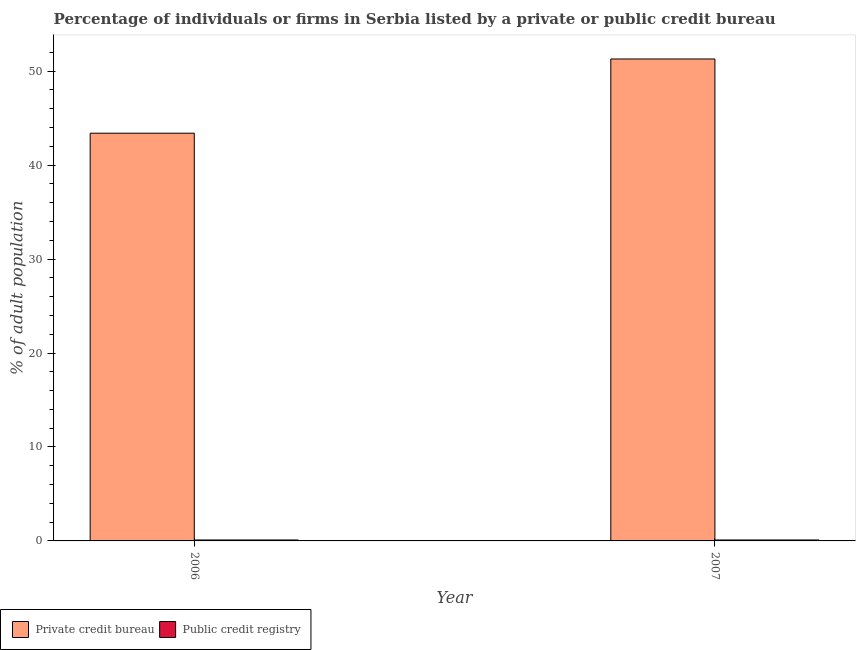How many different coloured bars are there?
Your response must be concise. 2. How many groups of bars are there?
Make the answer very short. 2. Are the number of bars on each tick of the X-axis equal?
Offer a very short reply. Yes. What is the label of the 2nd group of bars from the left?
Your answer should be compact. 2007. What is the percentage of firms listed by private credit bureau in 2006?
Ensure brevity in your answer.  43.4. Across all years, what is the maximum percentage of firms listed by private credit bureau?
Keep it short and to the point. 51.3. Across all years, what is the minimum percentage of firms listed by private credit bureau?
Give a very brief answer. 43.4. In which year was the percentage of firms listed by public credit bureau minimum?
Make the answer very short. 2006. What is the total percentage of firms listed by private credit bureau in the graph?
Provide a short and direct response. 94.7. What is the difference between the percentage of firms listed by public credit bureau in 2006 and that in 2007?
Your answer should be very brief. 0. What is the difference between the percentage of firms listed by public credit bureau in 2006 and the percentage of firms listed by private credit bureau in 2007?
Make the answer very short. 0. What is the average percentage of firms listed by private credit bureau per year?
Make the answer very short. 47.35. In the year 2007, what is the difference between the percentage of firms listed by private credit bureau and percentage of firms listed by public credit bureau?
Offer a very short reply. 0. In how many years, is the percentage of firms listed by public credit bureau greater than 8 %?
Your answer should be compact. 0. What is the ratio of the percentage of firms listed by private credit bureau in 2006 to that in 2007?
Your answer should be very brief. 0.85. In how many years, is the percentage of firms listed by private credit bureau greater than the average percentage of firms listed by private credit bureau taken over all years?
Ensure brevity in your answer.  1. What does the 2nd bar from the left in 2006 represents?
Provide a short and direct response. Public credit registry. What does the 1st bar from the right in 2007 represents?
Your answer should be very brief. Public credit registry. How many bars are there?
Provide a succinct answer. 4. How many years are there in the graph?
Your response must be concise. 2. What is the difference between two consecutive major ticks on the Y-axis?
Your answer should be very brief. 10. Does the graph contain any zero values?
Ensure brevity in your answer.  No. Where does the legend appear in the graph?
Offer a terse response. Bottom left. What is the title of the graph?
Keep it short and to the point. Percentage of individuals or firms in Serbia listed by a private or public credit bureau. What is the label or title of the X-axis?
Keep it short and to the point. Year. What is the label or title of the Y-axis?
Your answer should be very brief. % of adult population. What is the % of adult population of Private credit bureau in 2006?
Provide a short and direct response. 43.4. What is the % of adult population in Private credit bureau in 2007?
Provide a short and direct response. 51.3. What is the % of adult population of Public credit registry in 2007?
Ensure brevity in your answer.  0.1. Across all years, what is the maximum % of adult population in Private credit bureau?
Keep it short and to the point. 51.3. Across all years, what is the maximum % of adult population of Public credit registry?
Make the answer very short. 0.1. Across all years, what is the minimum % of adult population in Private credit bureau?
Make the answer very short. 43.4. What is the total % of adult population in Private credit bureau in the graph?
Give a very brief answer. 94.7. What is the total % of adult population of Public credit registry in the graph?
Your answer should be very brief. 0.2. What is the difference between the % of adult population in Private credit bureau in 2006 and that in 2007?
Provide a succinct answer. -7.9. What is the difference between the % of adult population in Private credit bureau in 2006 and the % of adult population in Public credit registry in 2007?
Your answer should be compact. 43.3. What is the average % of adult population of Private credit bureau per year?
Provide a succinct answer. 47.35. What is the average % of adult population of Public credit registry per year?
Provide a short and direct response. 0.1. In the year 2006, what is the difference between the % of adult population in Private credit bureau and % of adult population in Public credit registry?
Offer a terse response. 43.3. In the year 2007, what is the difference between the % of adult population of Private credit bureau and % of adult population of Public credit registry?
Ensure brevity in your answer.  51.2. What is the ratio of the % of adult population of Private credit bureau in 2006 to that in 2007?
Provide a short and direct response. 0.85. What is the difference between the highest and the second highest % of adult population of Public credit registry?
Your answer should be very brief. 0. What is the difference between the highest and the lowest % of adult population of Public credit registry?
Your answer should be compact. 0. 